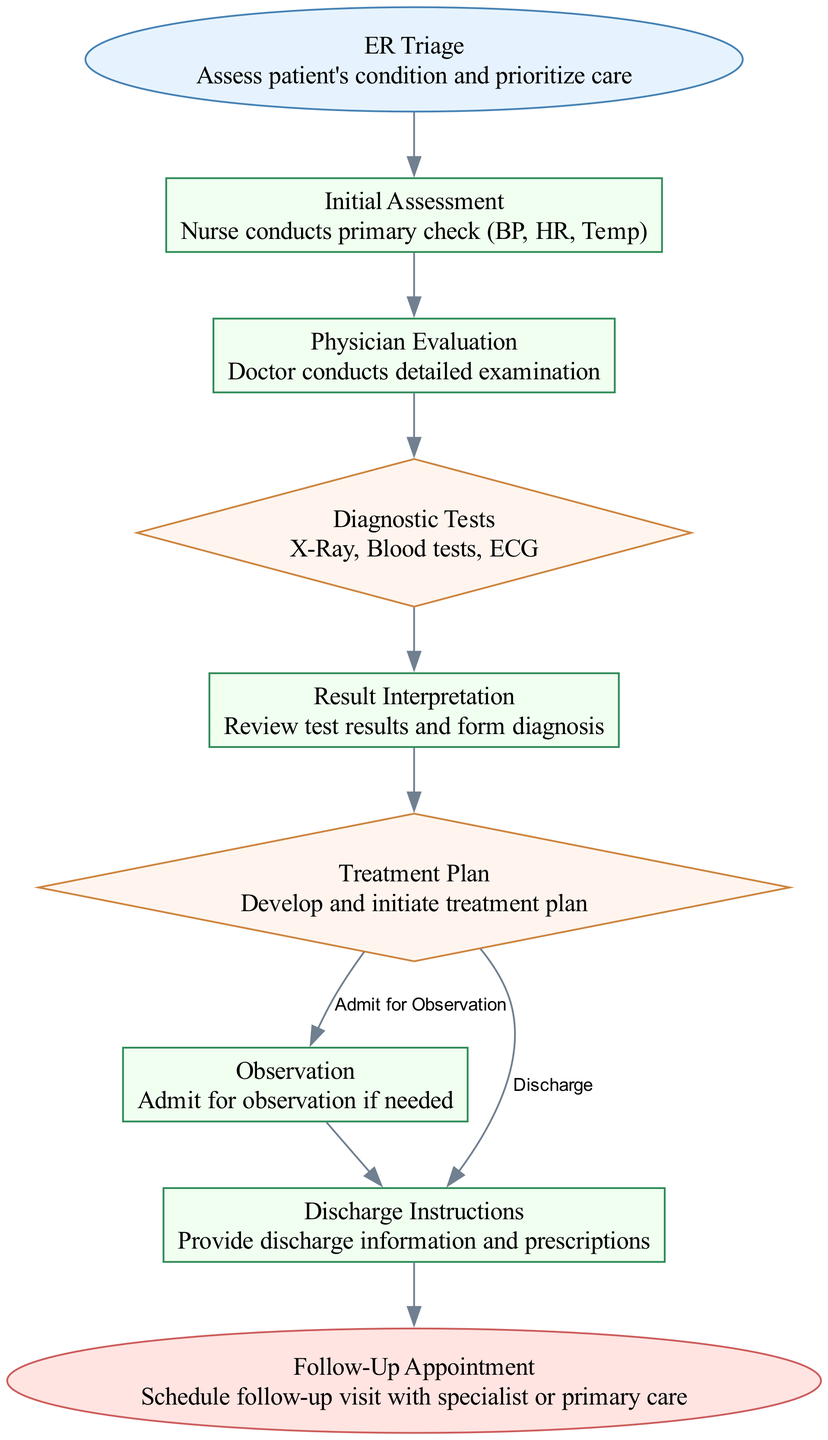What is the first step in the process? The diagram begins with "ER Triage," which is the initial step for assessing the patient's condition and prioritizing care.
Answer: ER Triage How many nodes are in the diagram? Counting each labeled point in the pathway, there are a total of nine distinct nodes represented, each indicating a specific step in the process.
Answer: 9 What type of node is "Result Interpretation"? By examining the node, we can see that "Result Interpretation" is categorized as a "Process," indicating that it involves a series of actions rather than a decision point or endpoint.
Answer: Process What is the condition leading to "Discharge Instructions"? The path leading to "Discharge Instructions" occurs when there is a "Discharge" decision after the Treatment Plan, guiding the flow into providing discharge details to the patient.
Answer: Discharge What follows 'Diagnostic Tests' in the flow? After "Diagnostic Tests," the next step is "Result Interpretation," where the outcomes from the tests are reviewed to form a diagnosis, indicating a progression of analysis.
Answer: Result Interpretation If a patient is admitted for observation, what is the next step? Following the observation admission, the process continues to "Discharge Instructions," where the necessary information and prescriptions are provided before the final appointment scheduling.
Answer: Discharge Instructions How many decision nodes are present in the diagram? The diagram shows three decision nodes, which include "Diagnostic Tests," "Treatment Plan," and the options stemming from "Treatment Plan," contributing to the decision-making process.
Answer: 3 Which node is considered the endpoint? The endpoint of the clinical pathway is represented by "Follow-Up Appointment," marking the conclusion of the emergency room admission and the transition to post-care arrangements.
Answer: Follow-Up Appointment What is the process immediately after 'Physician Evaluation'? The immediate action following 'Physician Evaluation' is 'Diagnostic Tests', where various medical assessments are performed to gather crucial information about the patient's condition.
Answer: Diagnostic Tests 